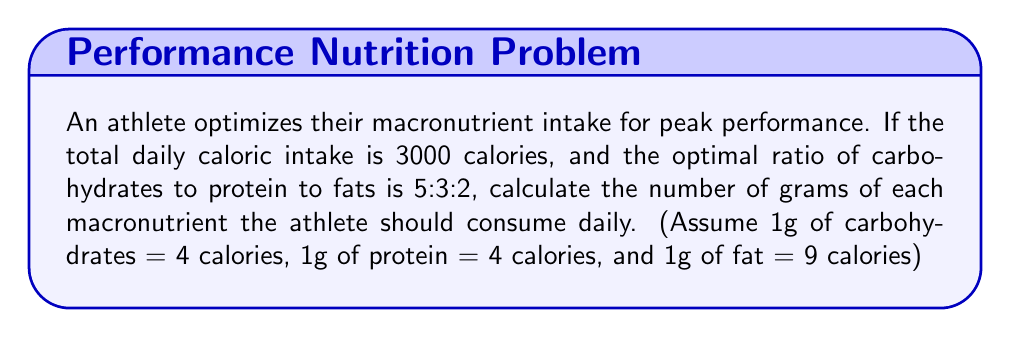Show me your answer to this math problem. 1. Calculate the fraction of total calories for each macronutrient:
   Total ratio parts = 5 + 3 + 2 = 10
   Carbohydrates: 5/10 = 1/2
   Protein: 3/10
   Fats: 2/10 = 1/5

2. Calculate calories for each macronutrient:
   Carbohydrates: $3000 \cdot \frac{1}{2} = 1500$ calories
   Protein: $3000 \cdot \frac{3}{10} = 900$ calories
   Fats: $3000 \cdot \frac{1}{5} = 600$ calories

3. Convert calories to grams:
   Carbohydrates: $\frac{1500 \text{ calories}}{4 \text{ calories/g}} = 375$ g
   Protein: $\frac{900 \text{ calories}}{4 \text{ calories/g}} = 225$ g
   Fats: $\frac{600 \text{ calories}}{9 \text{ calories/g}} = 66.67$ g

4. Round fat grams to the nearest whole number: 67 g
Answer: 375g carbohydrates, 225g protein, 67g fats 